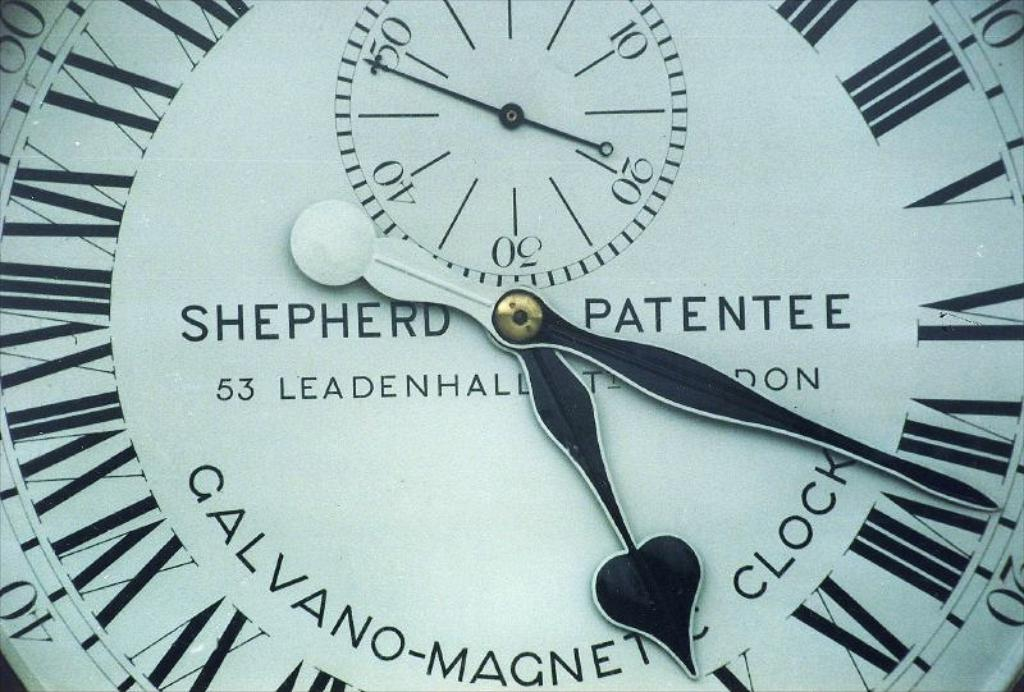What kind of mechanism might this type of clock use? This type of clock typically uses a pendulum-driven mechanism, which during its era was renowned for providing highly precise timekeeping, crucial for the various demands of urban and scientific applications. How is the maintenance performed on such historical clocks to preserve their accuracy and aesthetics? Maintenance involves regular cleaning, lubrication, and sometimes part replacements by skilled clockmakers who use traditional techniques to preserve both functionality and historical integrity, ensuring they run smoothly while retaining their original character. 